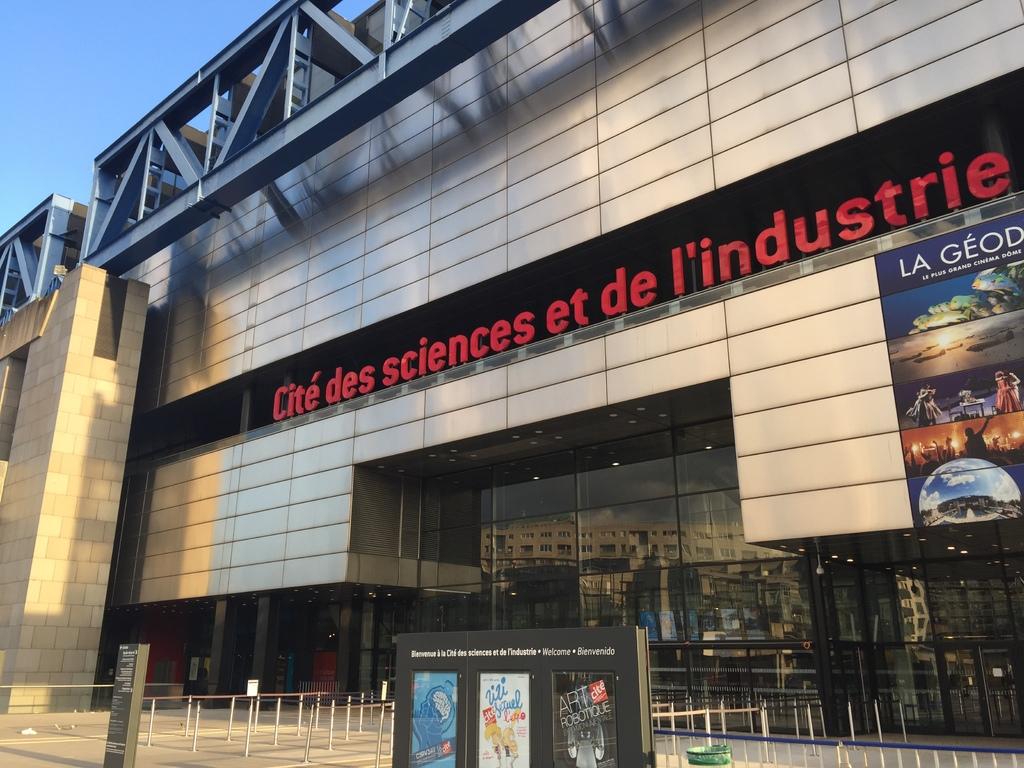What's the name of this building?
Give a very brief answer. Cite des sciences et de l'industrie. 